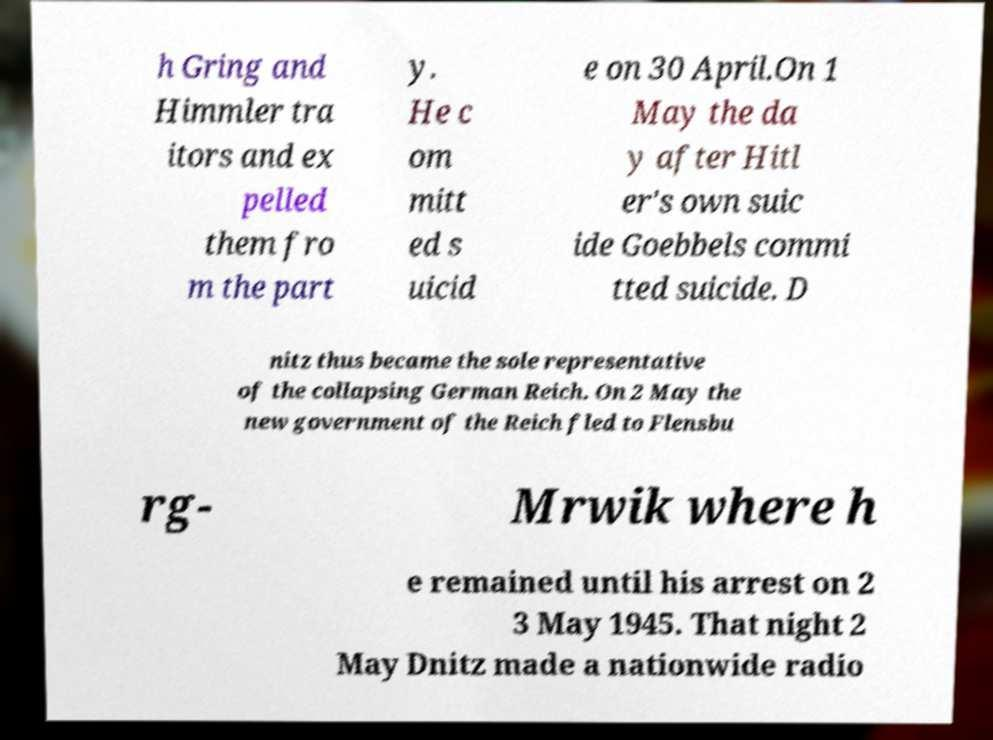Can you accurately transcribe the text from the provided image for me? h Gring and Himmler tra itors and ex pelled them fro m the part y. He c om mitt ed s uicid e on 30 April.On 1 May the da y after Hitl er's own suic ide Goebbels commi tted suicide. D nitz thus became the sole representative of the collapsing German Reich. On 2 May the new government of the Reich fled to Flensbu rg- Mrwik where h e remained until his arrest on 2 3 May 1945. That night 2 May Dnitz made a nationwide radio 